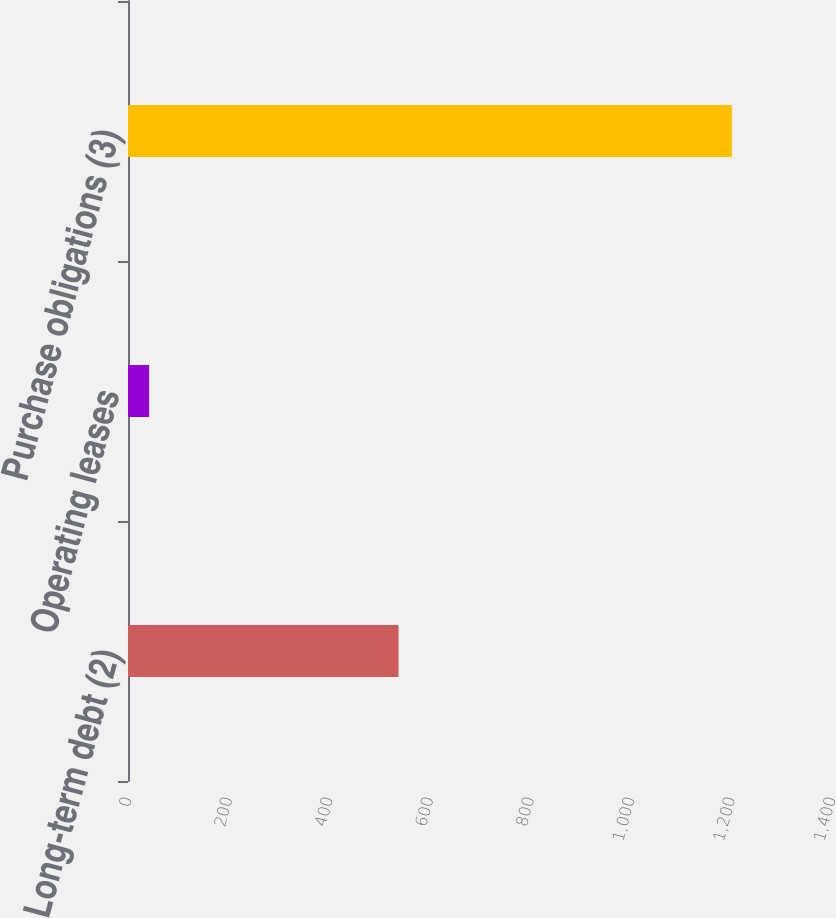Convert chart. <chart><loc_0><loc_0><loc_500><loc_500><bar_chart><fcel>Long-term debt (2)<fcel>Operating leases<fcel>Purchase obligations (3)<nl><fcel>538<fcel>42<fcel>1201<nl></chart> 